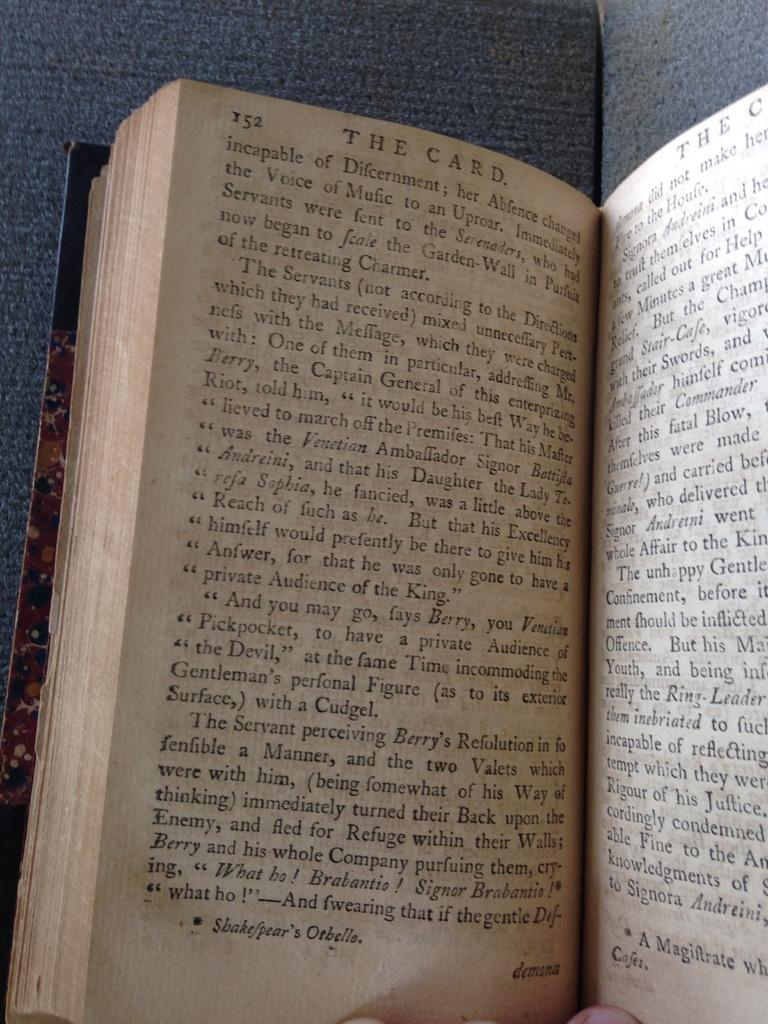<image>
Give a short and clear explanation of the subsequent image. The book shown is opened to the page 152. 